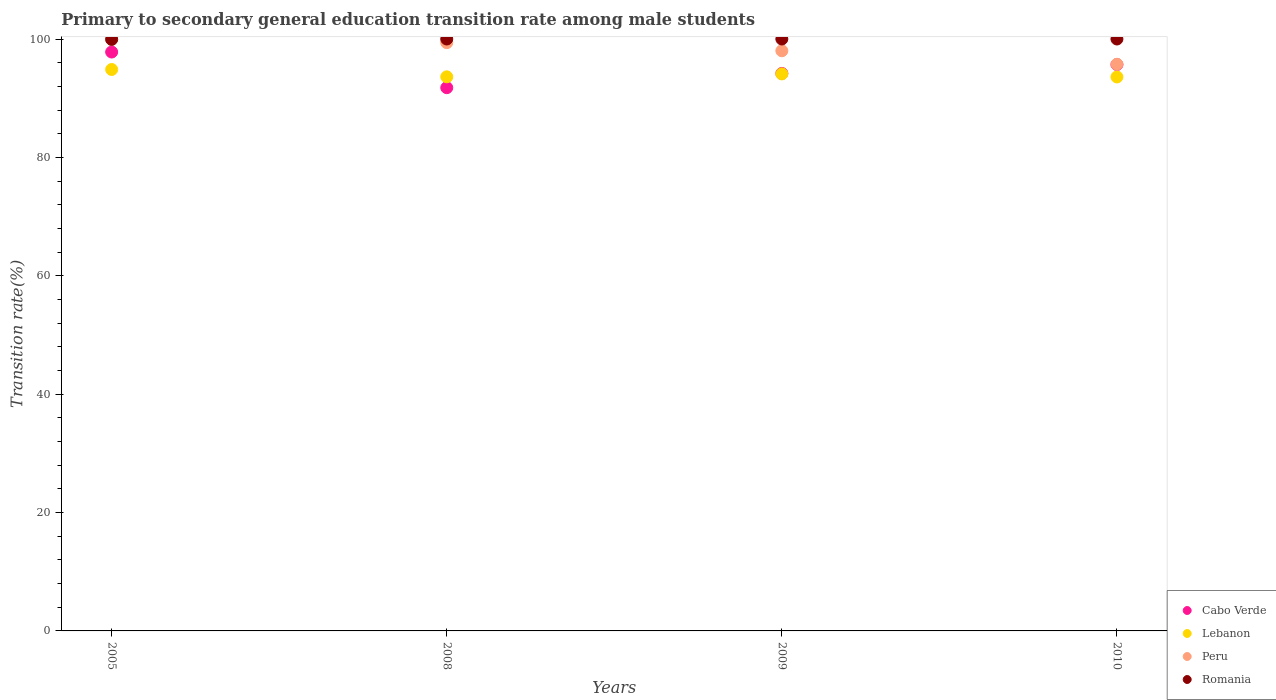How many different coloured dotlines are there?
Offer a very short reply. 4. What is the transition rate in Lebanon in 2009?
Your answer should be very brief. 94.11. Across all years, what is the maximum transition rate in Romania?
Provide a short and direct response. 100. Across all years, what is the minimum transition rate in Cabo Verde?
Ensure brevity in your answer.  91.78. In which year was the transition rate in Romania minimum?
Your answer should be compact. 2005. What is the total transition rate in Romania in the graph?
Offer a terse response. 399.93. What is the difference between the transition rate in Romania in 2010 and the transition rate in Cabo Verde in 2009?
Provide a succinct answer. 5.82. What is the average transition rate in Cabo Verde per year?
Make the answer very short. 94.86. In the year 2008, what is the difference between the transition rate in Cabo Verde and transition rate in Peru?
Offer a very short reply. -7.61. What is the ratio of the transition rate in Cabo Verde in 2008 to that in 2009?
Make the answer very short. 0.97. Is the difference between the transition rate in Cabo Verde in 2009 and 2010 greater than the difference between the transition rate in Peru in 2009 and 2010?
Offer a terse response. No. What is the difference between the highest and the second highest transition rate in Peru?
Your answer should be compact. 0.61. What is the difference between the highest and the lowest transition rate in Peru?
Give a very brief answer. 4.27. Does the transition rate in Lebanon monotonically increase over the years?
Offer a terse response. No. Is the transition rate in Romania strictly greater than the transition rate in Peru over the years?
Give a very brief answer. No. Is the transition rate in Romania strictly less than the transition rate in Peru over the years?
Offer a very short reply. No. How many dotlines are there?
Your answer should be compact. 4. Are the values on the major ticks of Y-axis written in scientific E-notation?
Offer a terse response. No. Does the graph contain grids?
Make the answer very short. No. Where does the legend appear in the graph?
Offer a very short reply. Bottom right. How many legend labels are there?
Ensure brevity in your answer.  4. What is the title of the graph?
Your answer should be compact. Primary to secondary general education transition rate among male students. What is the label or title of the X-axis?
Give a very brief answer. Years. What is the label or title of the Y-axis?
Give a very brief answer. Transition rate(%). What is the Transition rate(%) in Cabo Verde in 2005?
Your answer should be compact. 97.8. What is the Transition rate(%) in Lebanon in 2005?
Ensure brevity in your answer.  94.85. What is the Transition rate(%) in Romania in 2005?
Make the answer very short. 99.93. What is the Transition rate(%) in Cabo Verde in 2008?
Provide a short and direct response. 91.78. What is the Transition rate(%) in Lebanon in 2008?
Your response must be concise. 93.61. What is the Transition rate(%) in Peru in 2008?
Your answer should be compact. 99.39. What is the Transition rate(%) in Cabo Verde in 2009?
Ensure brevity in your answer.  94.18. What is the Transition rate(%) in Lebanon in 2009?
Your response must be concise. 94.11. What is the Transition rate(%) in Peru in 2009?
Your response must be concise. 98.01. What is the Transition rate(%) in Cabo Verde in 2010?
Offer a terse response. 95.69. What is the Transition rate(%) in Lebanon in 2010?
Your answer should be very brief. 93.59. What is the Transition rate(%) in Peru in 2010?
Make the answer very short. 95.73. What is the Transition rate(%) of Romania in 2010?
Keep it short and to the point. 100. Across all years, what is the maximum Transition rate(%) of Cabo Verde?
Your answer should be compact. 97.8. Across all years, what is the maximum Transition rate(%) in Lebanon?
Provide a short and direct response. 94.85. Across all years, what is the maximum Transition rate(%) in Peru?
Make the answer very short. 100. Across all years, what is the minimum Transition rate(%) in Cabo Verde?
Your answer should be compact. 91.78. Across all years, what is the minimum Transition rate(%) of Lebanon?
Your answer should be very brief. 93.59. Across all years, what is the minimum Transition rate(%) of Peru?
Make the answer very short. 95.73. Across all years, what is the minimum Transition rate(%) of Romania?
Ensure brevity in your answer.  99.93. What is the total Transition rate(%) of Cabo Verde in the graph?
Your answer should be very brief. 379.45. What is the total Transition rate(%) of Lebanon in the graph?
Offer a terse response. 376.16. What is the total Transition rate(%) of Peru in the graph?
Make the answer very short. 393.13. What is the total Transition rate(%) in Romania in the graph?
Your answer should be very brief. 399.93. What is the difference between the Transition rate(%) of Cabo Verde in 2005 and that in 2008?
Make the answer very short. 6.02. What is the difference between the Transition rate(%) of Lebanon in 2005 and that in 2008?
Offer a very short reply. 1.24. What is the difference between the Transition rate(%) of Peru in 2005 and that in 2008?
Offer a very short reply. 0.61. What is the difference between the Transition rate(%) of Romania in 2005 and that in 2008?
Keep it short and to the point. -0.07. What is the difference between the Transition rate(%) in Cabo Verde in 2005 and that in 2009?
Your response must be concise. 3.62. What is the difference between the Transition rate(%) in Lebanon in 2005 and that in 2009?
Your answer should be very brief. 0.74. What is the difference between the Transition rate(%) in Peru in 2005 and that in 2009?
Ensure brevity in your answer.  1.99. What is the difference between the Transition rate(%) in Romania in 2005 and that in 2009?
Make the answer very short. -0.07. What is the difference between the Transition rate(%) in Cabo Verde in 2005 and that in 2010?
Make the answer very short. 2.12. What is the difference between the Transition rate(%) in Lebanon in 2005 and that in 2010?
Your response must be concise. 1.26. What is the difference between the Transition rate(%) of Peru in 2005 and that in 2010?
Provide a short and direct response. 4.27. What is the difference between the Transition rate(%) in Romania in 2005 and that in 2010?
Offer a very short reply. -0.07. What is the difference between the Transition rate(%) of Cabo Verde in 2008 and that in 2009?
Ensure brevity in your answer.  -2.4. What is the difference between the Transition rate(%) of Lebanon in 2008 and that in 2009?
Provide a short and direct response. -0.49. What is the difference between the Transition rate(%) in Peru in 2008 and that in 2009?
Your answer should be compact. 1.38. What is the difference between the Transition rate(%) of Cabo Verde in 2008 and that in 2010?
Your answer should be compact. -3.91. What is the difference between the Transition rate(%) of Lebanon in 2008 and that in 2010?
Keep it short and to the point. 0.02. What is the difference between the Transition rate(%) in Peru in 2008 and that in 2010?
Keep it short and to the point. 3.66. What is the difference between the Transition rate(%) in Cabo Verde in 2009 and that in 2010?
Make the answer very short. -1.5. What is the difference between the Transition rate(%) of Lebanon in 2009 and that in 2010?
Your answer should be compact. 0.52. What is the difference between the Transition rate(%) of Peru in 2009 and that in 2010?
Your answer should be compact. 2.28. What is the difference between the Transition rate(%) of Romania in 2009 and that in 2010?
Offer a terse response. 0. What is the difference between the Transition rate(%) in Cabo Verde in 2005 and the Transition rate(%) in Lebanon in 2008?
Offer a very short reply. 4.19. What is the difference between the Transition rate(%) in Cabo Verde in 2005 and the Transition rate(%) in Peru in 2008?
Your answer should be very brief. -1.59. What is the difference between the Transition rate(%) of Cabo Verde in 2005 and the Transition rate(%) of Romania in 2008?
Keep it short and to the point. -2.2. What is the difference between the Transition rate(%) in Lebanon in 2005 and the Transition rate(%) in Peru in 2008?
Make the answer very short. -4.54. What is the difference between the Transition rate(%) in Lebanon in 2005 and the Transition rate(%) in Romania in 2008?
Keep it short and to the point. -5.15. What is the difference between the Transition rate(%) of Cabo Verde in 2005 and the Transition rate(%) of Lebanon in 2009?
Make the answer very short. 3.7. What is the difference between the Transition rate(%) of Cabo Verde in 2005 and the Transition rate(%) of Peru in 2009?
Give a very brief answer. -0.21. What is the difference between the Transition rate(%) of Cabo Verde in 2005 and the Transition rate(%) of Romania in 2009?
Keep it short and to the point. -2.2. What is the difference between the Transition rate(%) of Lebanon in 2005 and the Transition rate(%) of Peru in 2009?
Offer a terse response. -3.16. What is the difference between the Transition rate(%) of Lebanon in 2005 and the Transition rate(%) of Romania in 2009?
Give a very brief answer. -5.15. What is the difference between the Transition rate(%) of Peru in 2005 and the Transition rate(%) of Romania in 2009?
Your answer should be compact. 0. What is the difference between the Transition rate(%) in Cabo Verde in 2005 and the Transition rate(%) in Lebanon in 2010?
Make the answer very short. 4.21. What is the difference between the Transition rate(%) of Cabo Verde in 2005 and the Transition rate(%) of Peru in 2010?
Ensure brevity in your answer.  2.07. What is the difference between the Transition rate(%) in Cabo Verde in 2005 and the Transition rate(%) in Romania in 2010?
Provide a short and direct response. -2.2. What is the difference between the Transition rate(%) in Lebanon in 2005 and the Transition rate(%) in Peru in 2010?
Your answer should be very brief. -0.88. What is the difference between the Transition rate(%) of Lebanon in 2005 and the Transition rate(%) of Romania in 2010?
Offer a terse response. -5.15. What is the difference between the Transition rate(%) in Peru in 2005 and the Transition rate(%) in Romania in 2010?
Provide a succinct answer. 0. What is the difference between the Transition rate(%) of Cabo Verde in 2008 and the Transition rate(%) of Lebanon in 2009?
Make the answer very short. -2.33. What is the difference between the Transition rate(%) in Cabo Verde in 2008 and the Transition rate(%) in Peru in 2009?
Offer a terse response. -6.23. What is the difference between the Transition rate(%) of Cabo Verde in 2008 and the Transition rate(%) of Romania in 2009?
Provide a short and direct response. -8.22. What is the difference between the Transition rate(%) in Lebanon in 2008 and the Transition rate(%) in Peru in 2009?
Give a very brief answer. -4.4. What is the difference between the Transition rate(%) in Lebanon in 2008 and the Transition rate(%) in Romania in 2009?
Your answer should be very brief. -6.39. What is the difference between the Transition rate(%) of Peru in 2008 and the Transition rate(%) of Romania in 2009?
Provide a short and direct response. -0.61. What is the difference between the Transition rate(%) of Cabo Verde in 2008 and the Transition rate(%) of Lebanon in 2010?
Offer a terse response. -1.81. What is the difference between the Transition rate(%) of Cabo Verde in 2008 and the Transition rate(%) of Peru in 2010?
Your answer should be compact. -3.95. What is the difference between the Transition rate(%) in Cabo Verde in 2008 and the Transition rate(%) in Romania in 2010?
Keep it short and to the point. -8.22. What is the difference between the Transition rate(%) in Lebanon in 2008 and the Transition rate(%) in Peru in 2010?
Offer a very short reply. -2.12. What is the difference between the Transition rate(%) in Lebanon in 2008 and the Transition rate(%) in Romania in 2010?
Provide a short and direct response. -6.39. What is the difference between the Transition rate(%) of Peru in 2008 and the Transition rate(%) of Romania in 2010?
Provide a short and direct response. -0.61. What is the difference between the Transition rate(%) in Cabo Verde in 2009 and the Transition rate(%) in Lebanon in 2010?
Provide a short and direct response. 0.59. What is the difference between the Transition rate(%) of Cabo Verde in 2009 and the Transition rate(%) of Peru in 2010?
Your answer should be very brief. -1.55. What is the difference between the Transition rate(%) of Cabo Verde in 2009 and the Transition rate(%) of Romania in 2010?
Your response must be concise. -5.82. What is the difference between the Transition rate(%) in Lebanon in 2009 and the Transition rate(%) in Peru in 2010?
Keep it short and to the point. -1.62. What is the difference between the Transition rate(%) of Lebanon in 2009 and the Transition rate(%) of Romania in 2010?
Your answer should be very brief. -5.89. What is the difference between the Transition rate(%) of Peru in 2009 and the Transition rate(%) of Romania in 2010?
Provide a succinct answer. -1.99. What is the average Transition rate(%) in Cabo Verde per year?
Provide a succinct answer. 94.86. What is the average Transition rate(%) in Lebanon per year?
Provide a short and direct response. 94.04. What is the average Transition rate(%) in Peru per year?
Ensure brevity in your answer.  98.28. What is the average Transition rate(%) in Romania per year?
Offer a very short reply. 99.98. In the year 2005, what is the difference between the Transition rate(%) in Cabo Verde and Transition rate(%) in Lebanon?
Offer a very short reply. 2.95. In the year 2005, what is the difference between the Transition rate(%) of Cabo Verde and Transition rate(%) of Peru?
Provide a succinct answer. -2.2. In the year 2005, what is the difference between the Transition rate(%) in Cabo Verde and Transition rate(%) in Romania?
Your response must be concise. -2.13. In the year 2005, what is the difference between the Transition rate(%) of Lebanon and Transition rate(%) of Peru?
Make the answer very short. -5.15. In the year 2005, what is the difference between the Transition rate(%) of Lebanon and Transition rate(%) of Romania?
Provide a succinct answer. -5.08. In the year 2005, what is the difference between the Transition rate(%) in Peru and Transition rate(%) in Romania?
Offer a very short reply. 0.07. In the year 2008, what is the difference between the Transition rate(%) of Cabo Verde and Transition rate(%) of Lebanon?
Give a very brief answer. -1.83. In the year 2008, what is the difference between the Transition rate(%) of Cabo Verde and Transition rate(%) of Peru?
Your answer should be compact. -7.61. In the year 2008, what is the difference between the Transition rate(%) in Cabo Verde and Transition rate(%) in Romania?
Make the answer very short. -8.22. In the year 2008, what is the difference between the Transition rate(%) in Lebanon and Transition rate(%) in Peru?
Ensure brevity in your answer.  -5.78. In the year 2008, what is the difference between the Transition rate(%) in Lebanon and Transition rate(%) in Romania?
Make the answer very short. -6.39. In the year 2008, what is the difference between the Transition rate(%) of Peru and Transition rate(%) of Romania?
Provide a succinct answer. -0.61. In the year 2009, what is the difference between the Transition rate(%) of Cabo Verde and Transition rate(%) of Lebanon?
Offer a terse response. 0.08. In the year 2009, what is the difference between the Transition rate(%) in Cabo Verde and Transition rate(%) in Peru?
Offer a very short reply. -3.83. In the year 2009, what is the difference between the Transition rate(%) in Cabo Verde and Transition rate(%) in Romania?
Your answer should be very brief. -5.82. In the year 2009, what is the difference between the Transition rate(%) of Lebanon and Transition rate(%) of Peru?
Provide a short and direct response. -3.91. In the year 2009, what is the difference between the Transition rate(%) of Lebanon and Transition rate(%) of Romania?
Make the answer very short. -5.89. In the year 2009, what is the difference between the Transition rate(%) in Peru and Transition rate(%) in Romania?
Ensure brevity in your answer.  -1.99. In the year 2010, what is the difference between the Transition rate(%) of Cabo Verde and Transition rate(%) of Lebanon?
Make the answer very short. 2.1. In the year 2010, what is the difference between the Transition rate(%) in Cabo Verde and Transition rate(%) in Peru?
Keep it short and to the point. -0.04. In the year 2010, what is the difference between the Transition rate(%) in Cabo Verde and Transition rate(%) in Romania?
Keep it short and to the point. -4.31. In the year 2010, what is the difference between the Transition rate(%) of Lebanon and Transition rate(%) of Peru?
Offer a terse response. -2.14. In the year 2010, what is the difference between the Transition rate(%) of Lebanon and Transition rate(%) of Romania?
Give a very brief answer. -6.41. In the year 2010, what is the difference between the Transition rate(%) in Peru and Transition rate(%) in Romania?
Offer a terse response. -4.27. What is the ratio of the Transition rate(%) in Cabo Verde in 2005 to that in 2008?
Provide a succinct answer. 1.07. What is the ratio of the Transition rate(%) in Lebanon in 2005 to that in 2008?
Your answer should be compact. 1.01. What is the ratio of the Transition rate(%) of Peru in 2005 to that in 2008?
Keep it short and to the point. 1.01. What is the ratio of the Transition rate(%) of Romania in 2005 to that in 2008?
Provide a succinct answer. 1. What is the ratio of the Transition rate(%) in Cabo Verde in 2005 to that in 2009?
Provide a succinct answer. 1.04. What is the ratio of the Transition rate(%) in Lebanon in 2005 to that in 2009?
Offer a very short reply. 1.01. What is the ratio of the Transition rate(%) of Peru in 2005 to that in 2009?
Ensure brevity in your answer.  1.02. What is the ratio of the Transition rate(%) of Romania in 2005 to that in 2009?
Make the answer very short. 1. What is the ratio of the Transition rate(%) of Cabo Verde in 2005 to that in 2010?
Ensure brevity in your answer.  1.02. What is the ratio of the Transition rate(%) of Lebanon in 2005 to that in 2010?
Provide a short and direct response. 1.01. What is the ratio of the Transition rate(%) of Peru in 2005 to that in 2010?
Provide a short and direct response. 1.04. What is the ratio of the Transition rate(%) of Cabo Verde in 2008 to that in 2009?
Make the answer very short. 0.97. What is the ratio of the Transition rate(%) of Lebanon in 2008 to that in 2009?
Keep it short and to the point. 0.99. What is the ratio of the Transition rate(%) in Peru in 2008 to that in 2009?
Provide a succinct answer. 1.01. What is the ratio of the Transition rate(%) of Cabo Verde in 2008 to that in 2010?
Offer a terse response. 0.96. What is the ratio of the Transition rate(%) in Lebanon in 2008 to that in 2010?
Your answer should be compact. 1. What is the ratio of the Transition rate(%) in Peru in 2008 to that in 2010?
Your response must be concise. 1.04. What is the ratio of the Transition rate(%) of Cabo Verde in 2009 to that in 2010?
Give a very brief answer. 0.98. What is the ratio of the Transition rate(%) in Peru in 2009 to that in 2010?
Provide a succinct answer. 1.02. What is the ratio of the Transition rate(%) of Romania in 2009 to that in 2010?
Provide a short and direct response. 1. What is the difference between the highest and the second highest Transition rate(%) of Cabo Verde?
Provide a short and direct response. 2.12. What is the difference between the highest and the second highest Transition rate(%) of Lebanon?
Provide a succinct answer. 0.74. What is the difference between the highest and the second highest Transition rate(%) of Peru?
Provide a short and direct response. 0.61. What is the difference between the highest and the lowest Transition rate(%) in Cabo Verde?
Make the answer very short. 6.02. What is the difference between the highest and the lowest Transition rate(%) of Lebanon?
Your answer should be compact. 1.26. What is the difference between the highest and the lowest Transition rate(%) in Peru?
Give a very brief answer. 4.27. What is the difference between the highest and the lowest Transition rate(%) of Romania?
Offer a terse response. 0.07. 